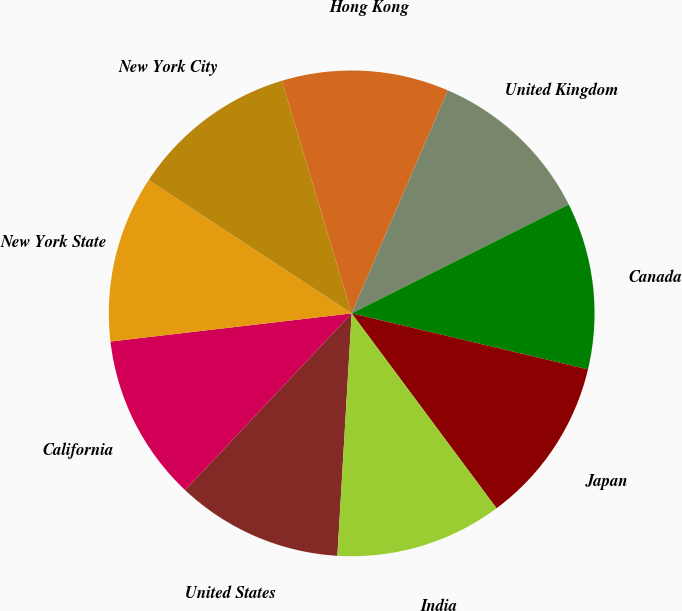Convert chart to OTSL. <chart><loc_0><loc_0><loc_500><loc_500><pie_chart><fcel>United States<fcel>California<fcel>New York State<fcel>New York City<fcel>Hong Kong<fcel>United Kingdom<fcel>Canada<fcel>Japan<fcel>India<nl><fcel>11.09%<fcel>11.12%<fcel>11.1%<fcel>11.11%<fcel>11.11%<fcel>11.13%<fcel>11.1%<fcel>11.12%<fcel>11.11%<nl></chart> 